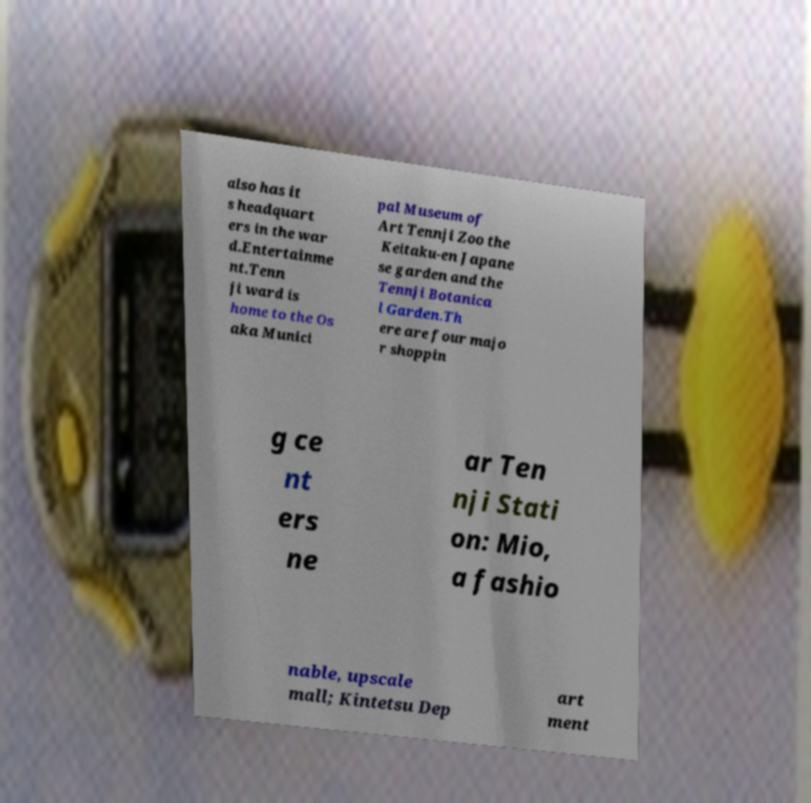For documentation purposes, I need the text within this image transcribed. Could you provide that? also has it s headquart ers in the war d.Entertainme nt.Tenn ji ward is home to the Os aka Munici pal Museum of Art Tennji Zoo the Keitaku-en Japane se garden and the Tennji Botanica l Garden.Th ere are four majo r shoppin g ce nt ers ne ar Ten nji Stati on: Mio, a fashio nable, upscale mall; Kintetsu Dep art ment 